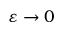<formula> <loc_0><loc_0><loc_500><loc_500>\varepsilon \to 0</formula> 